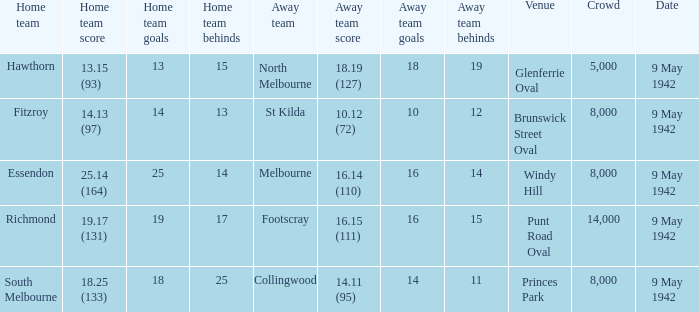How many people attended the game where Footscray was away? 14000.0. 